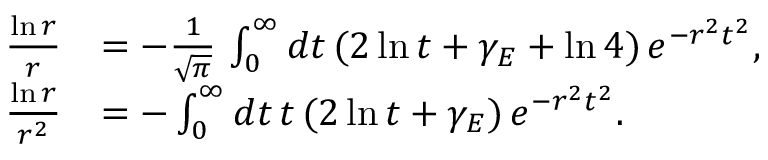Convert formula to latex. <formula><loc_0><loc_0><loc_500><loc_500>\begin{array} { r l } { \frac { \ln r } { r } } & { = - \frac { 1 } { \sqrt { \pi } } \, \int _ { 0 } ^ { \infty } d t \, ( 2 \ln t + \gamma _ { E } + \ln 4 ) \, e ^ { - r ^ { 2 } t ^ { 2 } } , } \\ { \frac { \ln r } { r ^ { 2 } } } & { = - \int _ { 0 } ^ { \infty } d t \, t \, ( 2 \ln t + \gamma _ { E } ) \, e ^ { - r ^ { 2 } t ^ { 2 } } . } \end{array}</formula> 